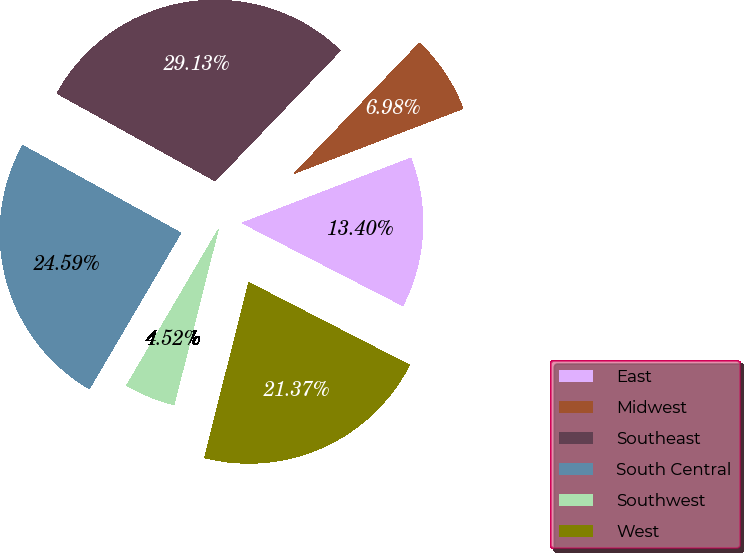Convert chart. <chart><loc_0><loc_0><loc_500><loc_500><pie_chart><fcel>East<fcel>Midwest<fcel>Southeast<fcel>South Central<fcel>Southwest<fcel>West<nl><fcel>13.4%<fcel>6.98%<fcel>29.13%<fcel>24.59%<fcel>4.52%<fcel>21.37%<nl></chart> 